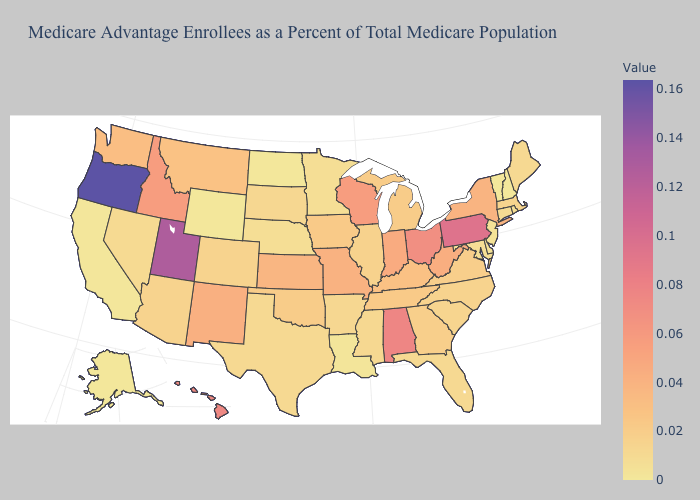Which states have the highest value in the USA?
Short answer required. Oregon. Is the legend a continuous bar?
Keep it brief. Yes. Among the states that border North Carolina , does Tennessee have the highest value?
Answer briefly. Yes. Which states have the lowest value in the USA?
Concise answer only. Alaska, North Dakota, Vermont, Wyoming. Which states have the lowest value in the Northeast?
Short answer required. Vermont. Among the states that border Minnesota , does Wisconsin have the highest value?
Be succinct. Yes. Does the map have missing data?
Answer briefly. No. 